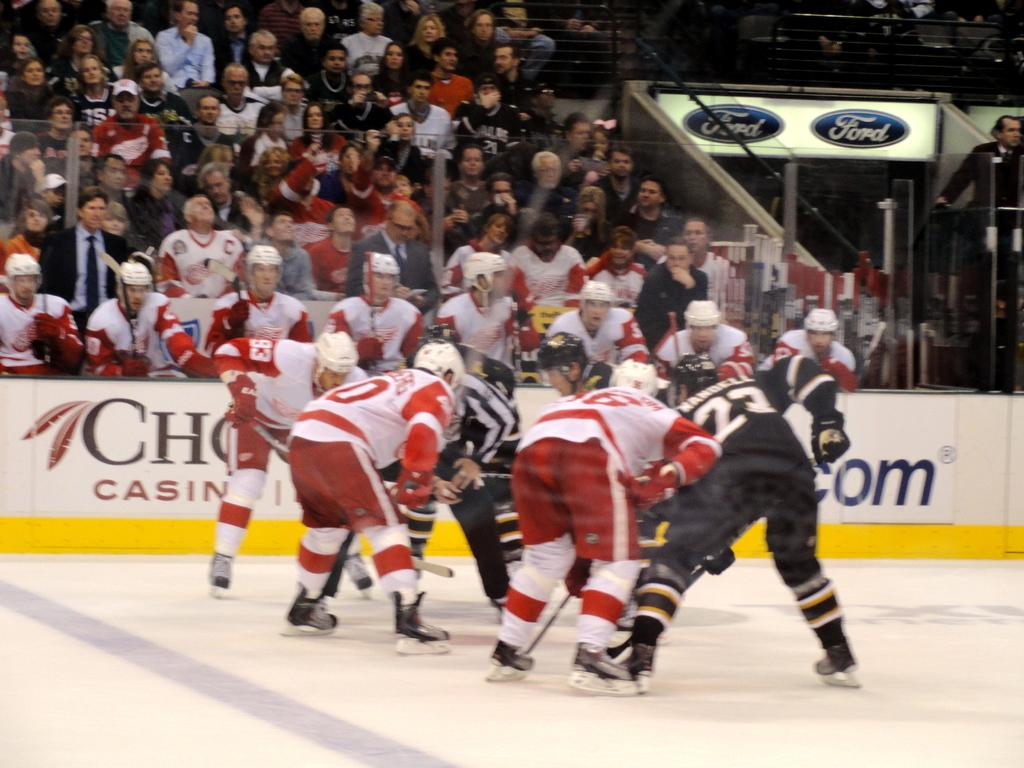What type of venue is shown in the image? The image depicts a stadium. What activity is taking place in the stadium? There are players gathered in the ground, suggesting that a game or match is being played. Who is watching the activity in the stadium? There are spectators watching the game. How many pipes are visible in the image? There are no pipes visible in the image; it depicts a stadium with players and spectators. 